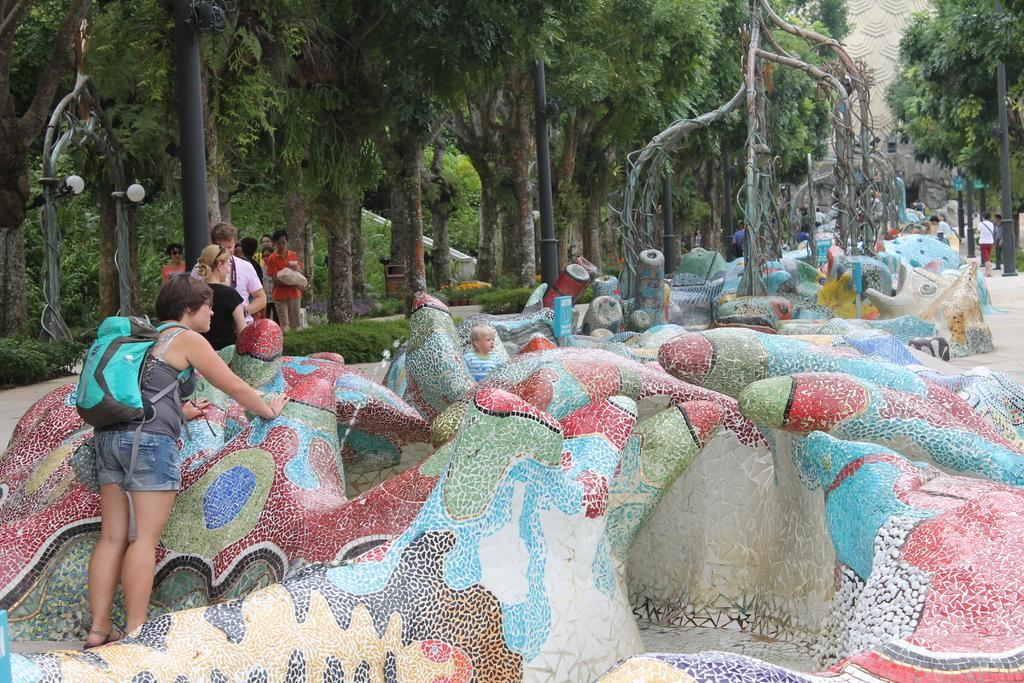What can be seen in the image related to art? There is some art in the image. Can you describe the people in the image? There are people in the image. What is the woman wearing in the image? A woman is wearing a backpack in the image. What can be seen in the background of the image? There are trees, poles, and lights in the background of the image. What type of salt is being used to decorate the cakes in the image? There are no cakes or salt present in the image. Can you describe the kiss between the two people in the image? There are no people kissing in the image; they are simply present. 